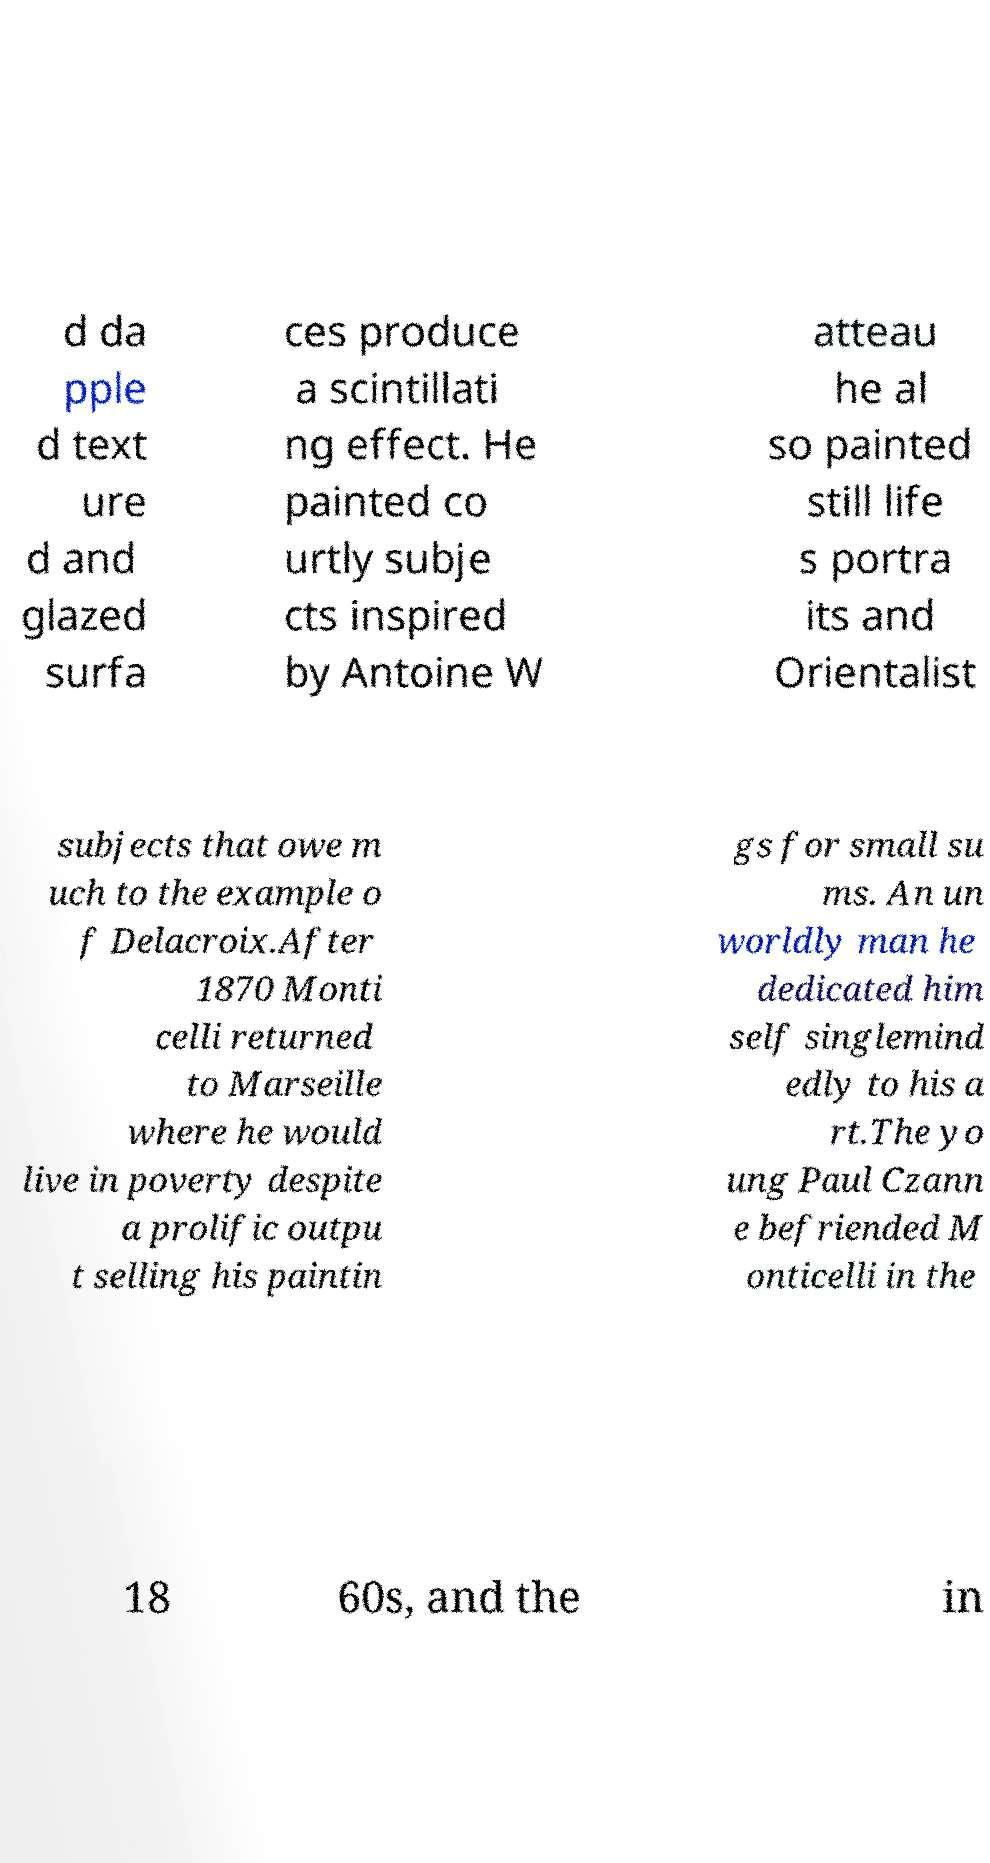Can you accurately transcribe the text from the provided image for me? d da pple d text ure d and glazed surfa ces produce a scintillati ng effect. He painted co urtly subje cts inspired by Antoine W atteau he al so painted still life s portra its and Orientalist subjects that owe m uch to the example o f Delacroix.After 1870 Monti celli returned to Marseille where he would live in poverty despite a prolific outpu t selling his paintin gs for small su ms. An un worldly man he dedicated him self singlemind edly to his a rt.The yo ung Paul Czann e befriended M onticelli in the 18 60s, and the in 